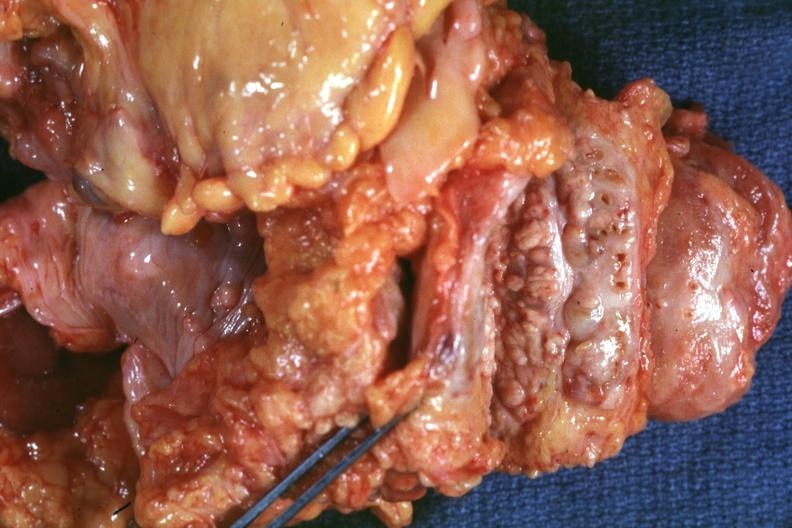what intervening tumor tissue very good?
Answer the question using a single word or phrase. Nodular parenchyma and dense 